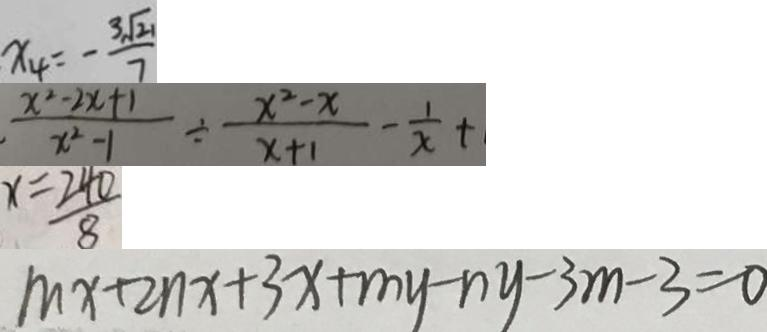Convert formula to latex. <formula><loc_0><loc_0><loc_500><loc_500>x _ { 4 } = - \frac { 3 \sqrt { 2 1 } } { 7 } 
 \frac { x ^ { 2 } - 2 x + 1 } { x ^ { 2 } - 1 } \div \frac { x ^ { 2 } - x } { x + 1 } - \frac { 1 } { x } + 
 x = \frac { 2 4 0 } { 8 } 
 m x + 2 n x + 3 x + m y - n y - 3 m - 3 = 0</formula> 